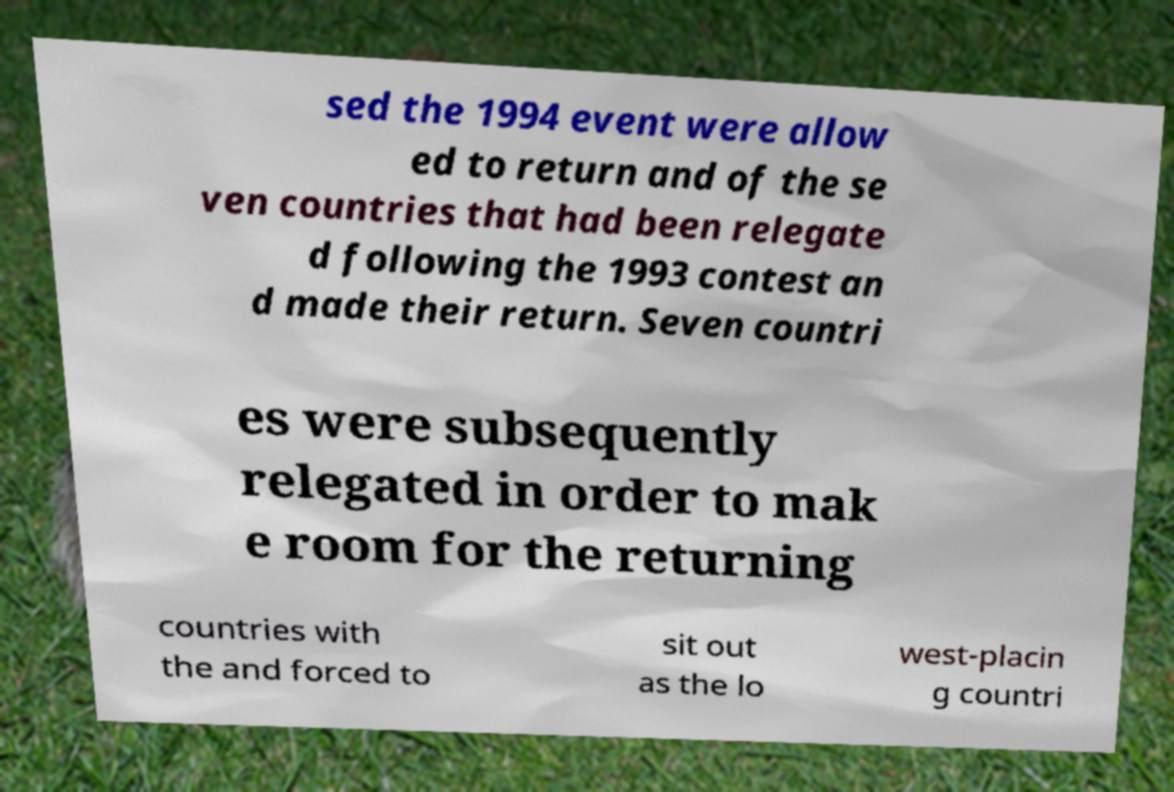Please identify and transcribe the text found in this image. sed the 1994 event were allow ed to return and of the se ven countries that had been relegate d following the 1993 contest an d made their return. Seven countri es were subsequently relegated in order to mak e room for the returning countries with the and forced to sit out as the lo west-placin g countri 